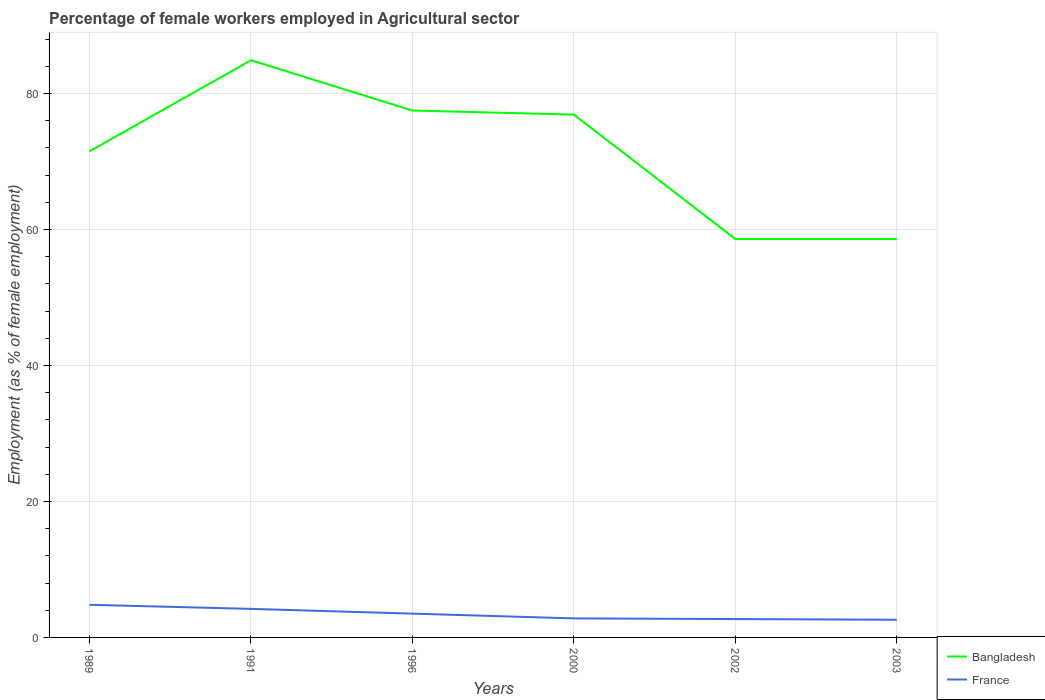Does the line corresponding to Bangladesh intersect with the line corresponding to France?
Provide a short and direct response. No. Is the number of lines equal to the number of legend labels?
Provide a short and direct response. Yes. Across all years, what is the maximum percentage of females employed in Agricultural sector in Bangladesh?
Offer a very short reply. 58.6. In which year was the percentage of females employed in Agricultural sector in France maximum?
Your answer should be very brief. 2003. What is the total percentage of females employed in Agricultural sector in Bangladesh in the graph?
Offer a very short reply. -5.4. What is the difference between the highest and the second highest percentage of females employed in Agricultural sector in Bangladesh?
Make the answer very short. 26.3. Is the percentage of females employed in Agricultural sector in Bangladesh strictly greater than the percentage of females employed in Agricultural sector in France over the years?
Make the answer very short. No. Does the graph contain grids?
Ensure brevity in your answer.  Yes. Where does the legend appear in the graph?
Your answer should be compact. Bottom right. How many legend labels are there?
Offer a terse response. 2. How are the legend labels stacked?
Keep it short and to the point. Vertical. What is the title of the graph?
Ensure brevity in your answer.  Percentage of female workers employed in Agricultural sector. Does "Guinea-Bissau" appear as one of the legend labels in the graph?
Ensure brevity in your answer.  No. What is the label or title of the Y-axis?
Make the answer very short. Employment (as % of female employment). What is the Employment (as % of female employment) in Bangladesh in 1989?
Ensure brevity in your answer.  71.5. What is the Employment (as % of female employment) in France in 1989?
Offer a terse response. 4.8. What is the Employment (as % of female employment) of Bangladesh in 1991?
Ensure brevity in your answer.  84.9. What is the Employment (as % of female employment) in France in 1991?
Your answer should be very brief. 4.2. What is the Employment (as % of female employment) of Bangladesh in 1996?
Provide a succinct answer. 77.5. What is the Employment (as % of female employment) of France in 1996?
Keep it short and to the point. 3.5. What is the Employment (as % of female employment) of Bangladesh in 2000?
Ensure brevity in your answer.  76.9. What is the Employment (as % of female employment) of France in 2000?
Offer a very short reply. 2.8. What is the Employment (as % of female employment) in Bangladesh in 2002?
Give a very brief answer. 58.6. What is the Employment (as % of female employment) in France in 2002?
Offer a very short reply. 2.7. What is the Employment (as % of female employment) of Bangladesh in 2003?
Offer a very short reply. 58.6. What is the Employment (as % of female employment) in France in 2003?
Keep it short and to the point. 2.6. Across all years, what is the maximum Employment (as % of female employment) of Bangladesh?
Give a very brief answer. 84.9. Across all years, what is the maximum Employment (as % of female employment) in France?
Your answer should be very brief. 4.8. Across all years, what is the minimum Employment (as % of female employment) in Bangladesh?
Provide a short and direct response. 58.6. Across all years, what is the minimum Employment (as % of female employment) in France?
Offer a very short reply. 2.6. What is the total Employment (as % of female employment) in Bangladesh in the graph?
Provide a succinct answer. 428. What is the total Employment (as % of female employment) in France in the graph?
Give a very brief answer. 20.6. What is the difference between the Employment (as % of female employment) in France in 1989 and that in 1991?
Offer a terse response. 0.6. What is the difference between the Employment (as % of female employment) of France in 1989 and that in 1996?
Give a very brief answer. 1.3. What is the difference between the Employment (as % of female employment) in Bangladesh in 1989 and that in 2002?
Offer a very short reply. 12.9. What is the difference between the Employment (as % of female employment) of France in 1989 and that in 2002?
Make the answer very short. 2.1. What is the difference between the Employment (as % of female employment) of France in 1989 and that in 2003?
Ensure brevity in your answer.  2.2. What is the difference between the Employment (as % of female employment) in Bangladesh in 1991 and that in 1996?
Offer a terse response. 7.4. What is the difference between the Employment (as % of female employment) of France in 1991 and that in 1996?
Offer a very short reply. 0.7. What is the difference between the Employment (as % of female employment) in France in 1991 and that in 2000?
Give a very brief answer. 1.4. What is the difference between the Employment (as % of female employment) in Bangladesh in 1991 and that in 2002?
Give a very brief answer. 26.3. What is the difference between the Employment (as % of female employment) in France in 1991 and that in 2002?
Provide a succinct answer. 1.5. What is the difference between the Employment (as % of female employment) in Bangladesh in 1991 and that in 2003?
Keep it short and to the point. 26.3. What is the difference between the Employment (as % of female employment) of Bangladesh in 1996 and that in 2000?
Provide a succinct answer. 0.6. What is the difference between the Employment (as % of female employment) in Bangladesh in 1996 and that in 2003?
Make the answer very short. 18.9. What is the difference between the Employment (as % of female employment) of Bangladesh in 2000 and that in 2002?
Provide a short and direct response. 18.3. What is the difference between the Employment (as % of female employment) of France in 2000 and that in 2002?
Provide a short and direct response. 0.1. What is the difference between the Employment (as % of female employment) in France in 2000 and that in 2003?
Your response must be concise. 0.2. What is the difference between the Employment (as % of female employment) in Bangladesh in 2002 and that in 2003?
Provide a short and direct response. 0. What is the difference between the Employment (as % of female employment) of France in 2002 and that in 2003?
Give a very brief answer. 0.1. What is the difference between the Employment (as % of female employment) of Bangladesh in 1989 and the Employment (as % of female employment) of France in 1991?
Offer a terse response. 67.3. What is the difference between the Employment (as % of female employment) in Bangladesh in 1989 and the Employment (as % of female employment) in France in 2000?
Your answer should be very brief. 68.7. What is the difference between the Employment (as % of female employment) in Bangladesh in 1989 and the Employment (as % of female employment) in France in 2002?
Your answer should be very brief. 68.8. What is the difference between the Employment (as % of female employment) in Bangladesh in 1989 and the Employment (as % of female employment) in France in 2003?
Your answer should be very brief. 68.9. What is the difference between the Employment (as % of female employment) in Bangladesh in 1991 and the Employment (as % of female employment) in France in 1996?
Offer a very short reply. 81.4. What is the difference between the Employment (as % of female employment) of Bangladesh in 1991 and the Employment (as % of female employment) of France in 2000?
Ensure brevity in your answer.  82.1. What is the difference between the Employment (as % of female employment) in Bangladesh in 1991 and the Employment (as % of female employment) in France in 2002?
Offer a very short reply. 82.2. What is the difference between the Employment (as % of female employment) of Bangladesh in 1991 and the Employment (as % of female employment) of France in 2003?
Your answer should be very brief. 82.3. What is the difference between the Employment (as % of female employment) in Bangladesh in 1996 and the Employment (as % of female employment) in France in 2000?
Offer a very short reply. 74.7. What is the difference between the Employment (as % of female employment) in Bangladesh in 1996 and the Employment (as % of female employment) in France in 2002?
Provide a succinct answer. 74.8. What is the difference between the Employment (as % of female employment) in Bangladesh in 1996 and the Employment (as % of female employment) in France in 2003?
Provide a succinct answer. 74.9. What is the difference between the Employment (as % of female employment) in Bangladesh in 2000 and the Employment (as % of female employment) in France in 2002?
Offer a very short reply. 74.2. What is the difference between the Employment (as % of female employment) in Bangladesh in 2000 and the Employment (as % of female employment) in France in 2003?
Keep it short and to the point. 74.3. What is the difference between the Employment (as % of female employment) of Bangladesh in 2002 and the Employment (as % of female employment) of France in 2003?
Offer a very short reply. 56. What is the average Employment (as % of female employment) of Bangladesh per year?
Offer a very short reply. 71.33. What is the average Employment (as % of female employment) of France per year?
Your answer should be very brief. 3.43. In the year 1989, what is the difference between the Employment (as % of female employment) of Bangladesh and Employment (as % of female employment) of France?
Keep it short and to the point. 66.7. In the year 1991, what is the difference between the Employment (as % of female employment) of Bangladesh and Employment (as % of female employment) of France?
Your answer should be very brief. 80.7. In the year 2000, what is the difference between the Employment (as % of female employment) in Bangladesh and Employment (as % of female employment) in France?
Your response must be concise. 74.1. In the year 2002, what is the difference between the Employment (as % of female employment) of Bangladesh and Employment (as % of female employment) of France?
Keep it short and to the point. 55.9. In the year 2003, what is the difference between the Employment (as % of female employment) of Bangladesh and Employment (as % of female employment) of France?
Ensure brevity in your answer.  56. What is the ratio of the Employment (as % of female employment) of Bangladesh in 1989 to that in 1991?
Your response must be concise. 0.84. What is the ratio of the Employment (as % of female employment) of France in 1989 to that in 1991?
Provide a succinct answer. 1.14. What is the ratio of the Employment (as % of female employment) in Bangladesh in 1989 to that in 1996?
Your response must be concise. 0.92. What is the ratio of the Employment (as % of female employment) of France in 1989 to that in 1996?
Your answer should be very brief. 1.37. What is the ratio of the Employment (as % of female employment) of Bangladesh in 1989 to that in 2000?
Offer a terse response. 0.93. What is the ratio of the Employment (as % of female employment) in France in 1989 to that in 2000?
Your answer should be very brief. 1.71. What is the ratio of the Employment (as % of female employment) of Bangladesh in 1989 to that in 2002?
Provide a succinct answer. 1.22. What is the ratio of the Employment (as % of female employment) of France in 1989 to that in 2002?
Provide a short and direct response. 1.78. What is the ratio of the Employment (as % of female employment) in Bangladesh in 1989 to that in 2003?
Your answer should be very brief. 1.22. What is the ratio of the Employment (as % of female employment) in France in 1989 to that in 2003?
Give a very brief answer. 1.85. What is the ratio of the Employment (as % of female employment) of Bangladesh in 1991 to that in 1996?
Your answer should be compact. 1.1. What is the ratio of the Employment (as % of female employment) of Bangladesh in 1991 to that in 2000?
Provide a short and direct response. 1.1. What is the ratio of the Employment (as % of female employment) in France in 1991 to that in 2000?
Make the answer very short. 1.5. What is the ratio of the Employment (as % of female employment) in Bangladesh in 1991 to that in 2002?
Offer a terse response. 1.45. What is the ratio of the Employment (as % of female employment) of France in 1991 to that in 2002?
Provide a succinct answer. 1.56. What is the ratio of the Employment (as % of female employment) in Bangladesh in 1991 to that in 2003?
Give a very brief answer. 1.45. What is the ratio of the Employment (as % of female employment) of France in 1991 to that in 2003?
Keep it short and to the point. 1.62. What is the ratio of the Employment (as % of female employment) in Bangladesh in 1996 to that in 2000?
Keep it short and to the point. 1.01. What is the ratio of the Employment (as % of female employment) of Bangladesh in 1996 to that in 2002?
Provide a short and direct response. 1.32. What is the ratio of the Employment (as % of female employment) of France in 1996 to that in 2002?
Your answer should be compact. 1.3. What is the ratio of the Employment (as % of female employment) in Bangladesh in 1996 to that in 2003?
Provide a short and direct response. 1.32. What is the ratio of the Employment (as % of female employment) in France in 1996 to that in 2003?
Make the answer very short. 1.35. What is the ratio of the Employment (as % of female employment) of Bangladesh in 2000 to that in 2002?
Your answer should be very brief. 1.31. What is the ratio of the Employment (as % of female employment) in Bangladesh in 2000 to that in 2003?
Offer a very short reply. 1.31. What is the ratio of the Employment (as % of female employment) in France in 2000 to that in 2003?
Your response must be concise. 1.08. What is the ratio of the Employment (as % of female employment) of France in 2002 to that in 2003?
Keep it short and to the point. 1.04. What is the difference between the highest and the second highest Employment (as % of female employment) in France?
Provide a short and direct response. 0.6. What is the difference between the highest and the lowest Employment (as % of female employment) of Bangladesh?
Your answer should be compact. 26.3. What is the difference between the highest and the lowest Employment (as % of female employment) in France?
Make the answer very short. 2.2. 